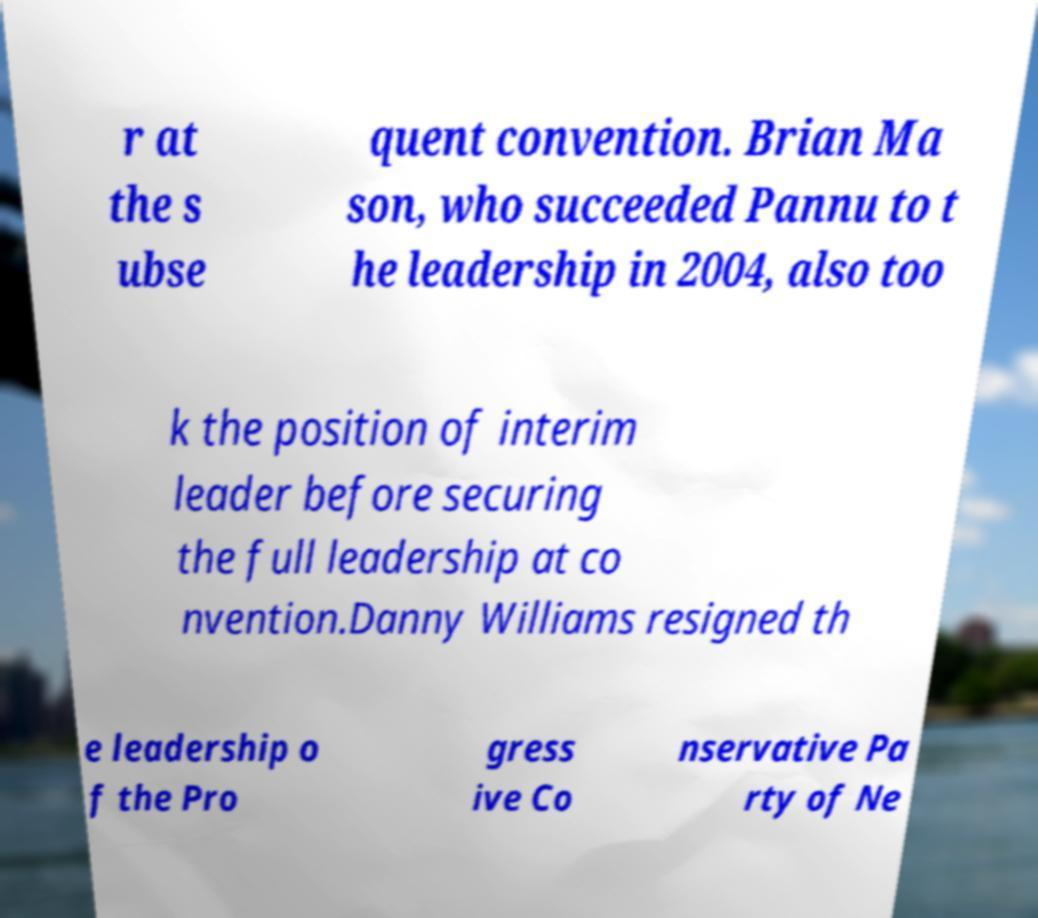Could you assist in decoding the text presented in this image and type it out clearly? r at the s ubse quent convention. Brian Ma son, who succeeded Pannu to t he leadership in 2004, also too k the position of interim leader before securing the full leadership at co nvention.Danny Williams resigned th e leadership o f the Pro gress ive Co nservative Pa rty of Ne 